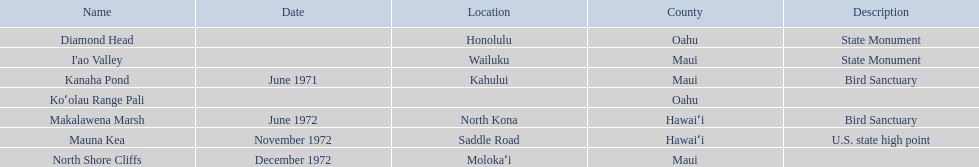What are all of the landmark names? Diamond Head, I'ao Valley, Kanaha Pond, Koʻolau Range Pali, Makalawena Marsh, Mauna Kea, North Shore Cliffs. Where are they located? Honolulu, Wailuku, Kahului, , North Kona, Saddle Road, Molokaʻi. And which landmark has no listed location? Koʻolau Range Pali. Write the full table. {'header': ['Name', 'Date', 'Location', 'County', 'Description'], 'rows': [['Diamond Head', '', 'Honolulu', 'Oahu', 'State Monument'], ["I'ao Valley", '', 'Wailuku', 'Maui', 'State Monument'], ['Kanaha Pond', 'June 1971', 'Kahului', 'Maui', 'Bird Sanctuary'], ['Koʻolau Range Pali', '', '', 'Oahu', ''], ['Makalawena Marsh', 'June 1972', 'North Kona', 'Hawaiʻi', 'Bird Sanctuary'], ['Mauna Kea', 'November 1972', 'Saddle Road', 'Hawaiʻi', 'U.S. state high point'], ['North Shore Cliffs', 'December 1972', 'Molokaʻi', 'Maui', '']]} 